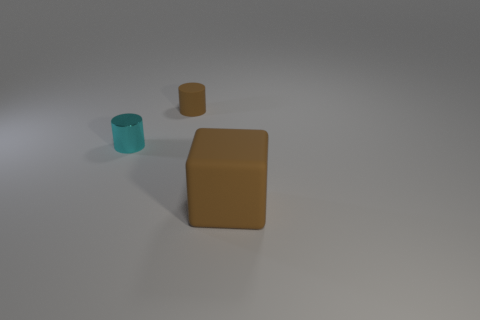Add 1 cyan metallic things. How many objects exist? 4 Subtract all cylinders. How many objects are left? 1 Add 3 small green cylinders. How many small green cylinders exist? 3 Subtract 0 yellow cubes. How many objects are left? 3 Subtract all large purple cylinders. Subtract all brown objects. How many objects are left? 1 Add 1 big brown matte blocks. How many big brown matte blocks are left? 2 